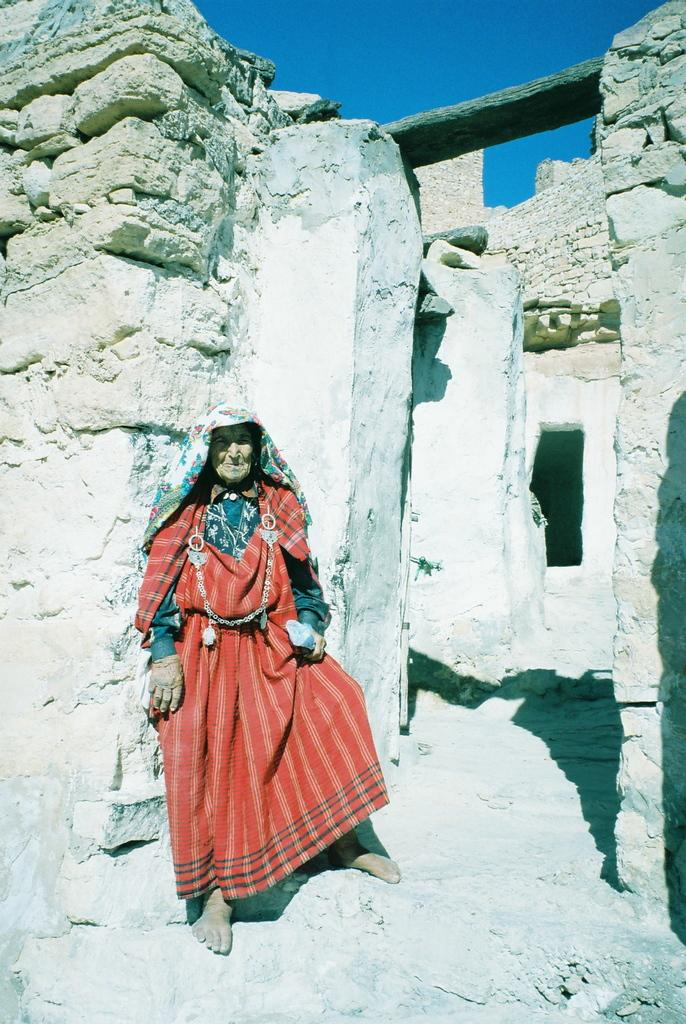Who is present in the image? There is a woman standing in the image. What can be seen behind the woman? Walls are visible in the image. What is visible in the distance in the image? The sky is visible in the background of the image. What type of shoe is the woman wearing in the image? There is no information about the woman's shoes in the image, so we cannot determine what type of shoe she is wearing. 